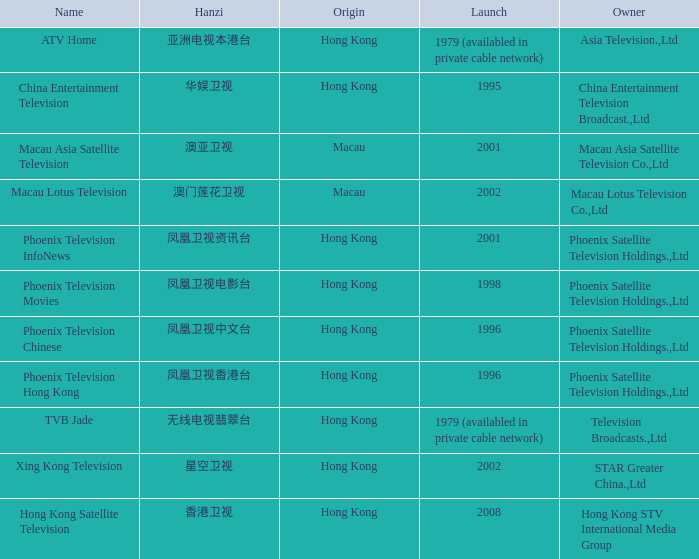What is the hanzi of phoenix television chinese that initiated in 1996? 凤凰卫视中文台. 